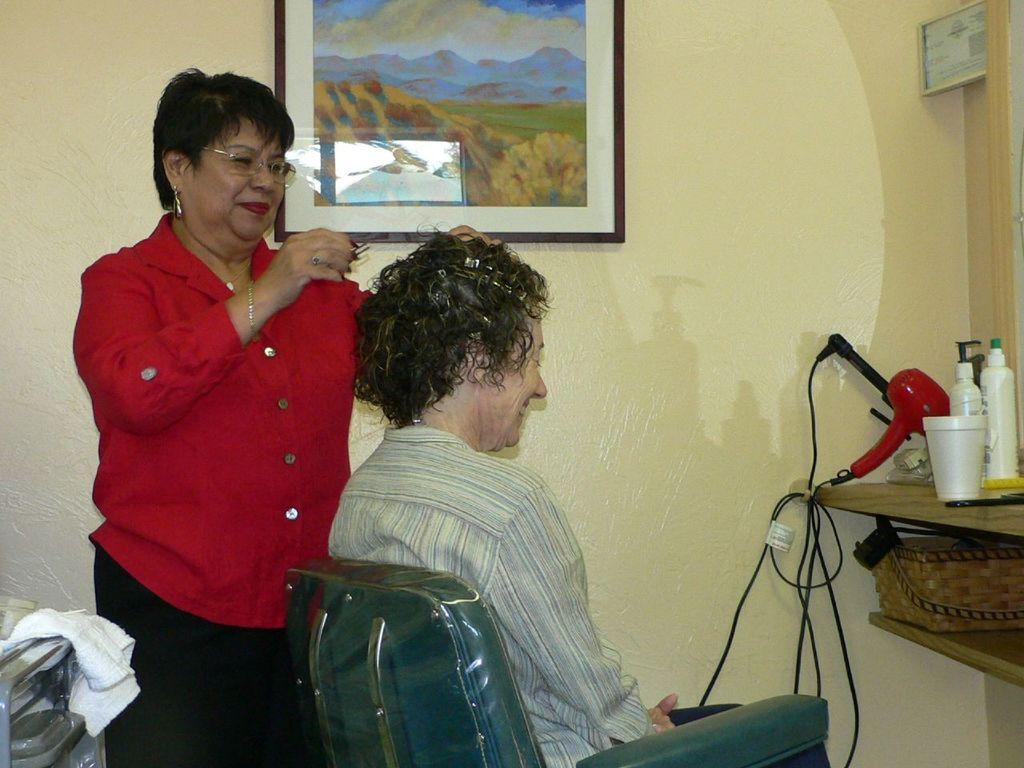How would you summarize this image in a sentence or two? In this picture I can see a human sitting on the chair and I can see a woman holding a clip in her hand and I can see a photo frame on the wall and I can see few bottles and a hair dryer on the table and I can see napkin. 